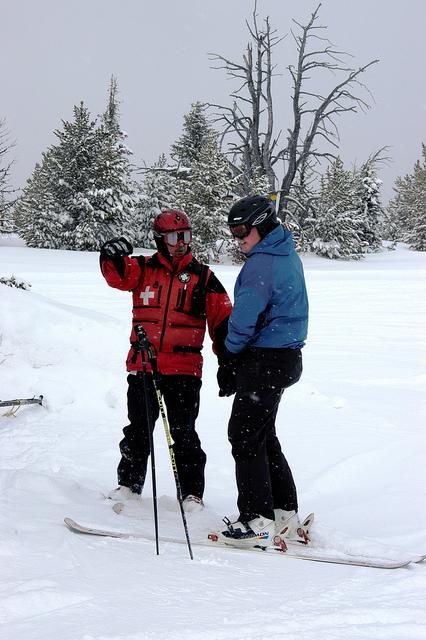What color is the person on the left wearing?
Give a very brief answer. Red. Are these people about to crash into each other?
Short answer required. No. Are the people currently skiing?
Be succinct. No. How many poles are there?
Answer briefly. 2. What sport is this?
Be succinct. Skiing. 